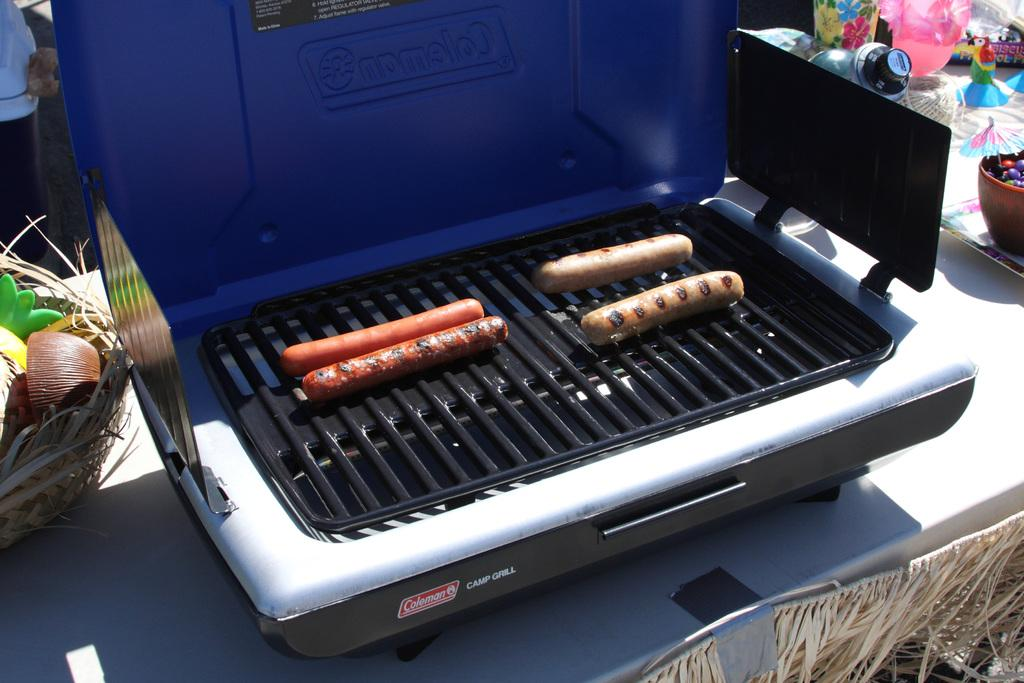<image>
Provide a brief description of the given image. Hot dogs cooking on a Coleman Camp Grill 